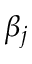Convert formula to latex. <formula><loc_0><loc_0><loc_500><loc_500>\beta _ { j }</formula> 